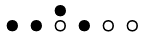<formula> <loc_0><loc_0><loc_500><loc_500>\begin{smallmatrix} & & \bullet \\ \bullet & \bullet & \circ & \bullet & \circ & \circ & \\ \end{smallmatrix}</formula> 